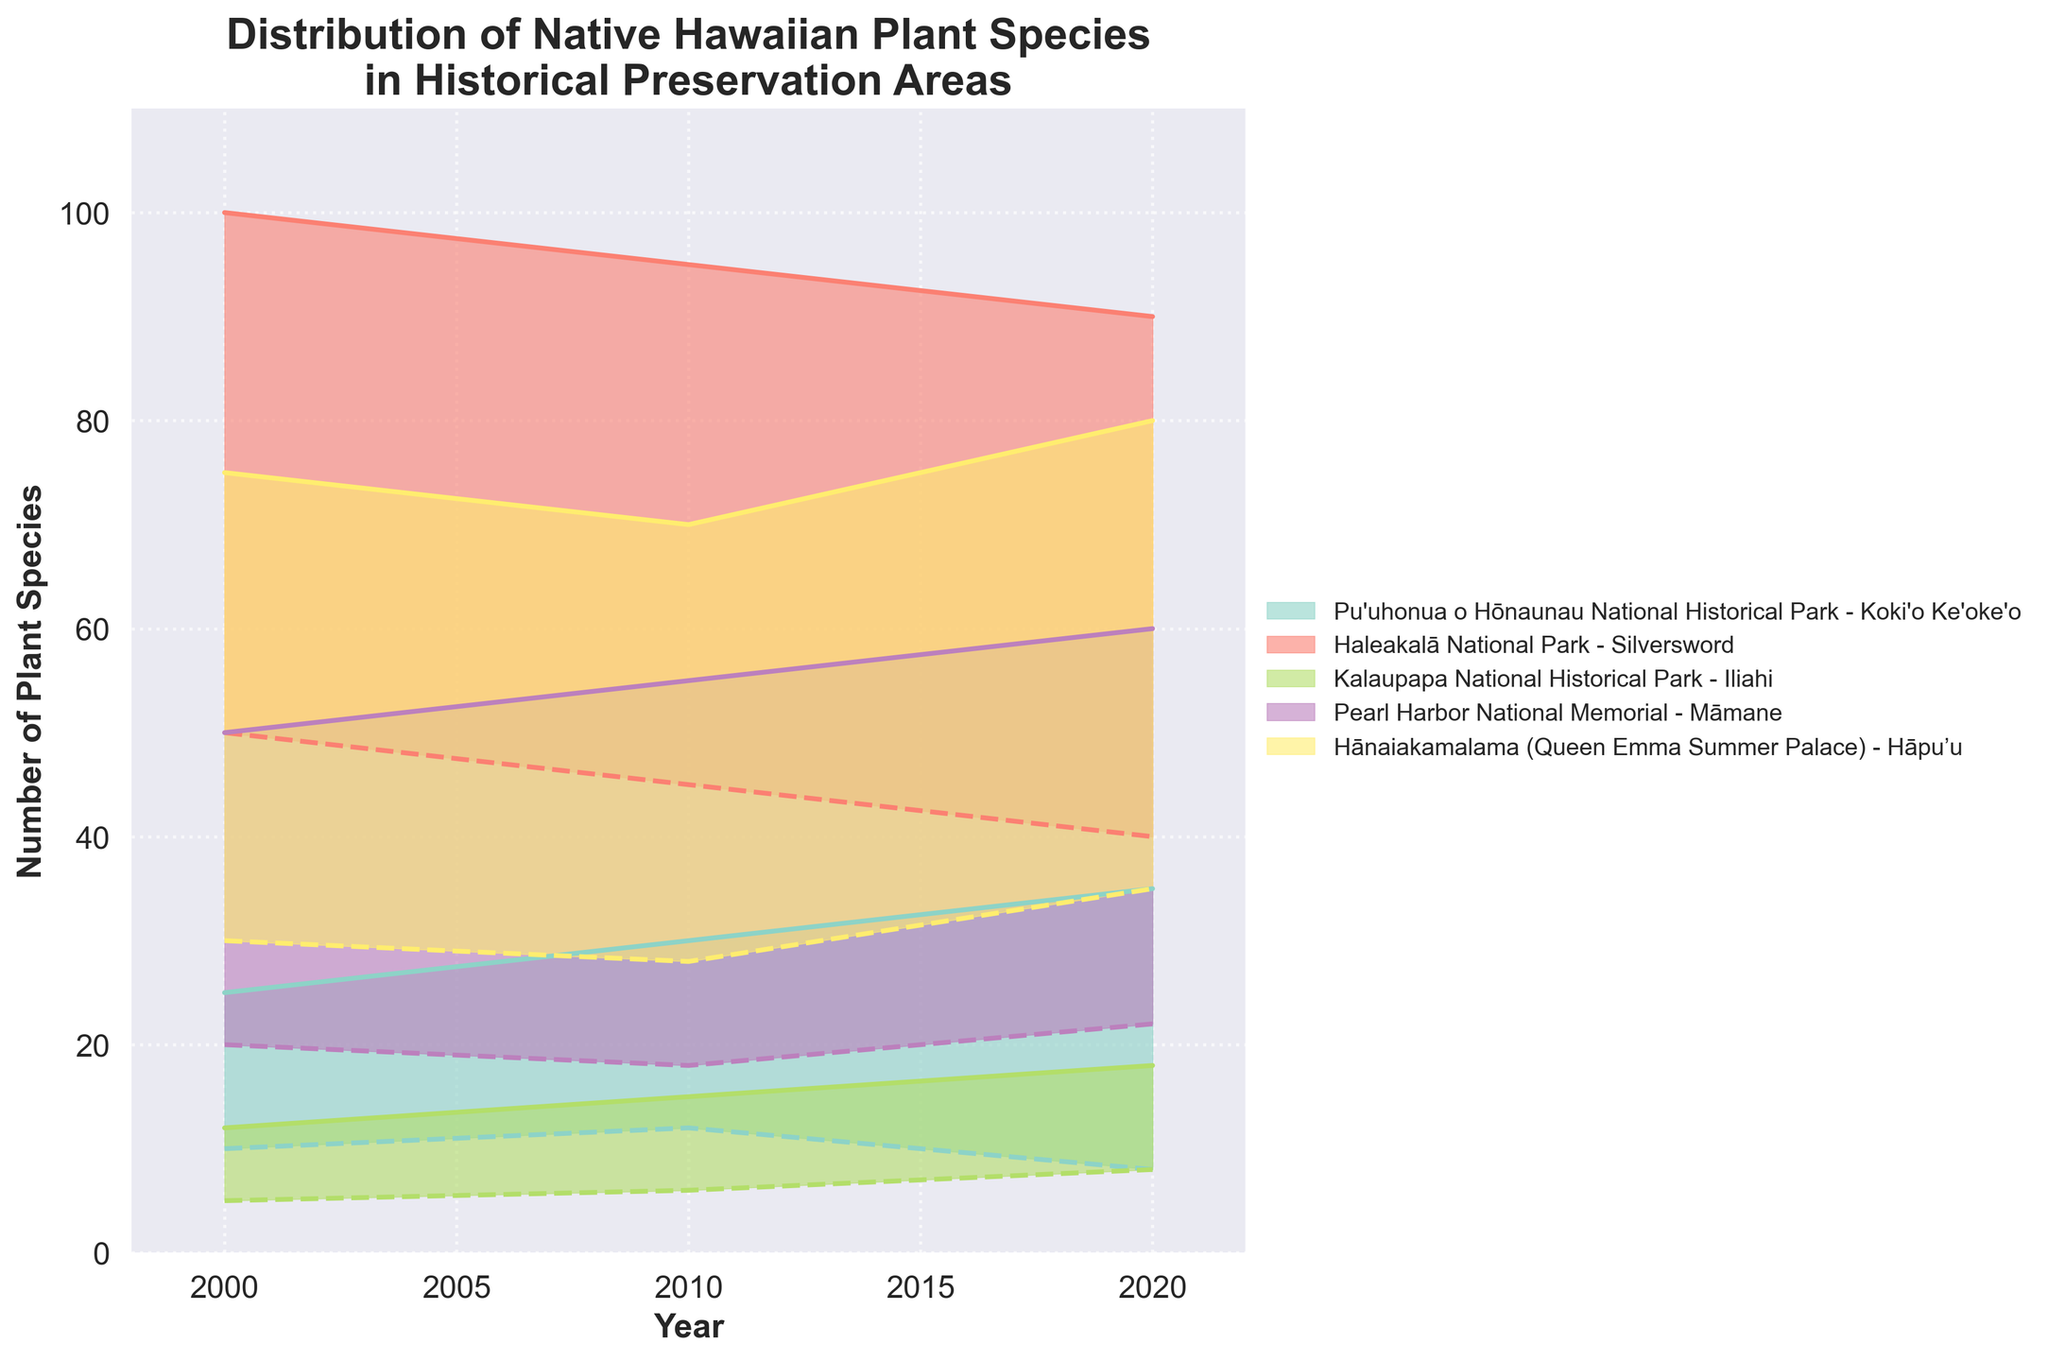What's the title of the figure? The title is generally located at the top of the figure and describes what the figure represents. In this case, the title is clear and directly mentioned at the top.
Answer: Distribution of Native Hawaiian Plant Species in Historical Preservation Areas What is the range of the Silversword species in Haleakalā National Park in the year 2000? To find the range for Silversword in Haleakalā National Park in 2000, locate the relevant plot section and read the lower and upper boundaries of the shaded area corresponding to that year.
Answer: 50 to 100 How many historical preservation areas are represented in the chart? Count the unique labels or shaded areas each representing a different historical preservation area.
Answer: 5 Which plant species has shown an increase in its minimum range from the year 2000 to 2020 in Kalaupapa National Historical Park? To identify the species with an increased minimum range, look at the start and end values of the lower boundary (minimum range) and compare them for the years 2000 and 2020 within the Kalaupapa National Historical Park section.
Answer: Iliahi What was the maximum range of Koki'o Ke'oke'o in Pu'uhonua o Hōnaunau National Historical Park in 2010? Locate the section for Pu'uhonua o Hōnaunau National Historical Park and identify the upper boundary (maximum range) for the year 2010 for Koki'o Ke'oke'o.
Answer: 30 Compare the change in the maximum range of Māmane in Pearl Harbor National Memorial between 2000 and 2020. Is it an increase or decrease? Look at the upper boundary values for Māmane in Pearl Harbor National Memorial for the years 2000 and 2020 and compare them to determine if the range increased or decreased.
Answer: Increase What are the minimum and maximum ranges for Hāpu’u in Hānaiakamalama (Queen Emma Summer Palace) in 2020? Find the section for Hānaiakamalama (Queen Emma Summer Palace) and read the lower and upper boundaries corresponding to the year 2020 for Hāpu’u.
Answer: 35 to 80 Comparing the year 2000, which historical preservation area had the highest minimum range for any plant species? Identify and compare the minimum range values across all historical preservation areas for the year 2000 and determine which is the highest.
Answer: Haleakalā National Park What is the general trend of the Silversword population in Haleakalā National Park from 2000 to 2020? Observe the trend line of the shaded area for Silversword in Haleakalā National Park to determine if the range is increasing, decreasing, or stable over time.
Answer: Decreasing Which historical preservation area experienced the largest increase in the maximum range of its plant species from 2000 to 2020? Compare the initial and final upper boundary values of each historical preservation area's plant species to see which had the largest increase over the time period.
Answer: Pu'uhonua o Hōnaunau National Historical Park 